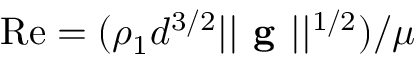Convert formula to latex. <formula><loc_0><loc_0><loc_500><loc_500>R e = ( \rho _ { 1 } d ^ { 3 / 2 } | | g | | ^ { 1 / 2 } ) / \mu</formula> 